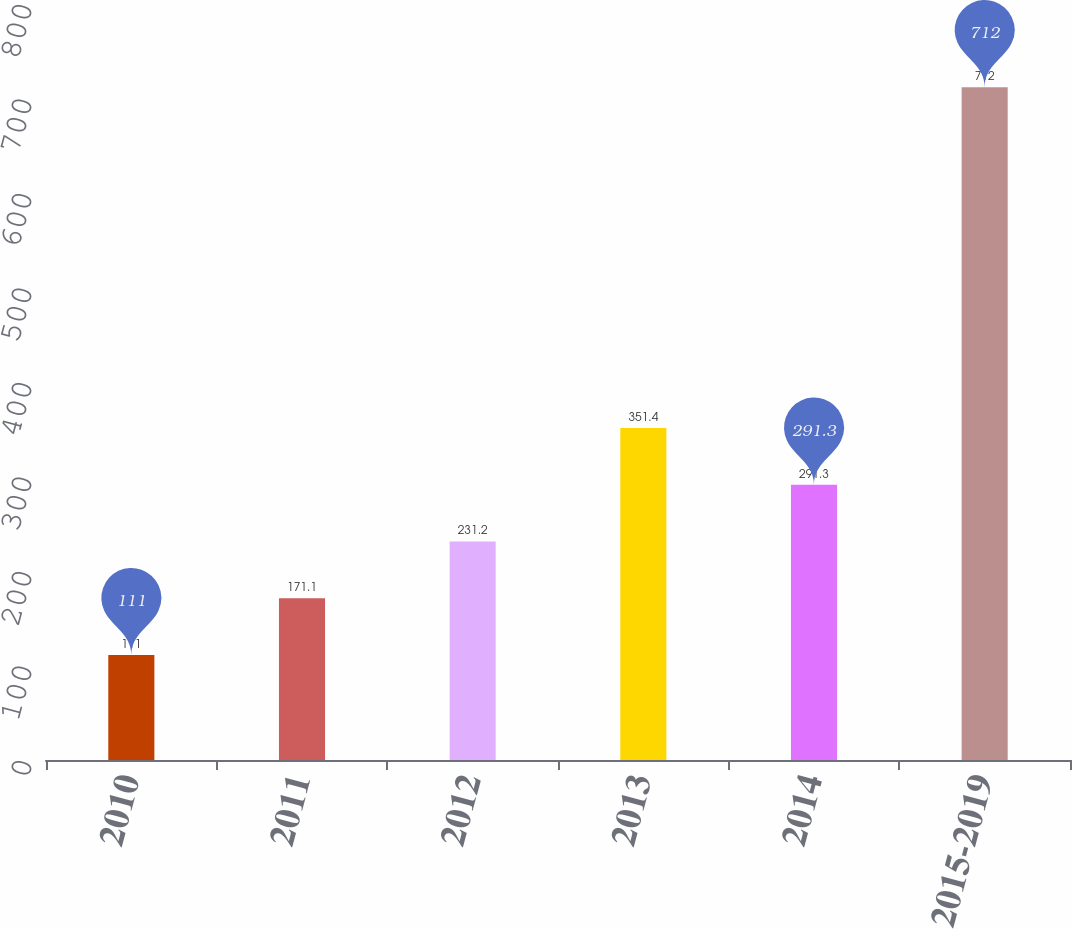Convert chart to OTSL. <chart><loc_0><loc_0><loc_500><loc_500><bar_chart><fcel>2010<fcel>2011<fcel>2012<fcel>2013<fcel>2014<fcel>2015-2019<nl><fcel>111<fcel>171.1<fcel>231.2<fcel>351.4<fcel>291.3<fcel>712<nl></chart> 